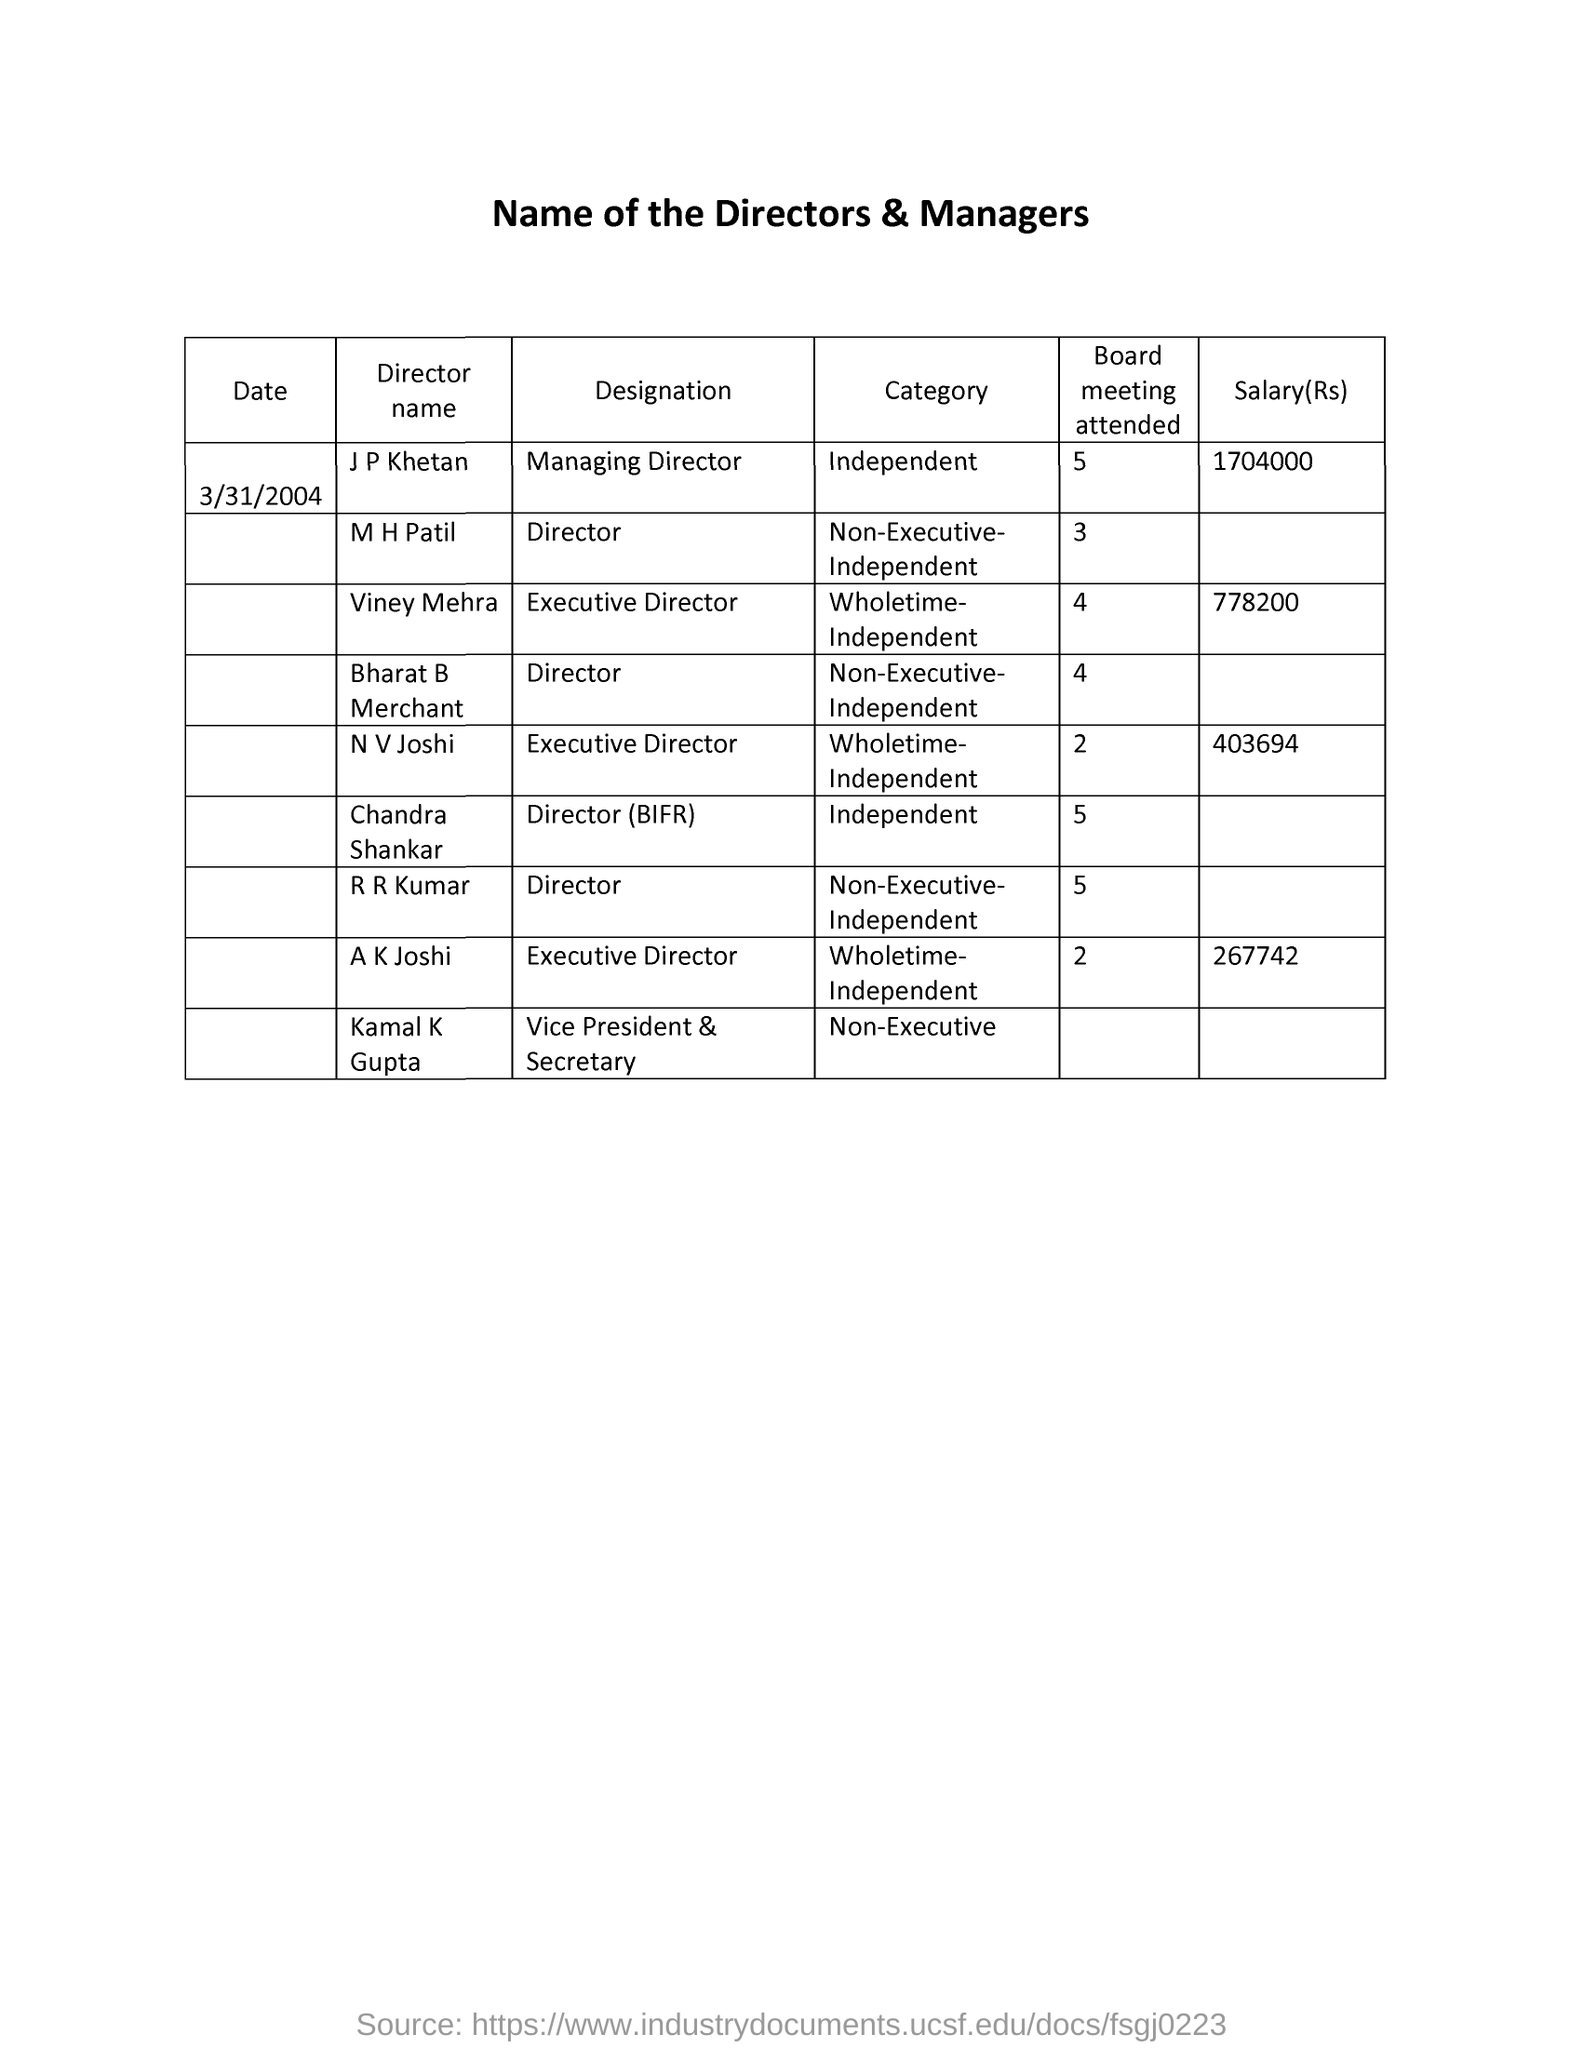What is the date mentioned?
Your response must be concise. 3/31/2004. What is the salary of the managing director ?
Offer a very short reply. 1704000. What is the salary of viney mehra
Offer a very short reply. 778200. What is the salary of nv joshi
Your answer should be very brief. 403694. What is the designation of mh patil
Your answer should be very brief. Director. What is the designation of viney mehra
Your response must be concise. Executive director. Who is the vice president & secretary ?
Your response must be concise. Kamal k gupta. What is the salary of ak joshi ?
Your answer should be compact. 267742. 